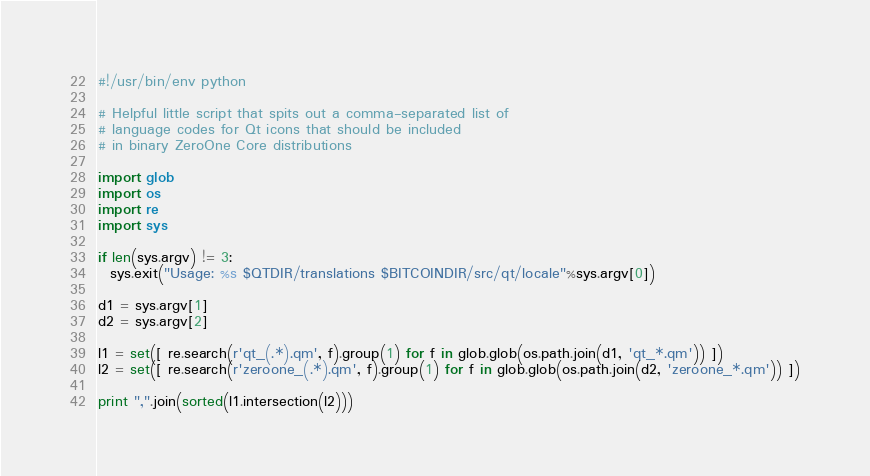Convert code to text. <code><loc_0><loc_0><loc_500><loc_500><_Python_>#!/usr/bin/env python

# Helpful little script that spits out a comma-separated list of
# language codes for Qt icons that should be included
# in binary ZeroOne Core distributions

import glob
import os
import re
import sys

if len(sys.argv) != 3:
  sys.exit("Usage: %s $QTDIR/translations $BITCOINDIR/src/qt/locale"%sys.argv[0])

d1 = sys.argv[1]
d2 = sys.argv[2]

l1 = set([ re.search(r'qt_(.*).qm', f).group(1) for f in glob.glob(os.path.join(d1, 'qt_*.qm')) ])
l2 = set([ re.search(r'zeroone_(.*).qm', f).group(1) for f in glob.glob(os.path.join(d2, 'zeroone_*.qm')) ])

print ",".join(sorted(l1.intersection(l2)))

</code> 